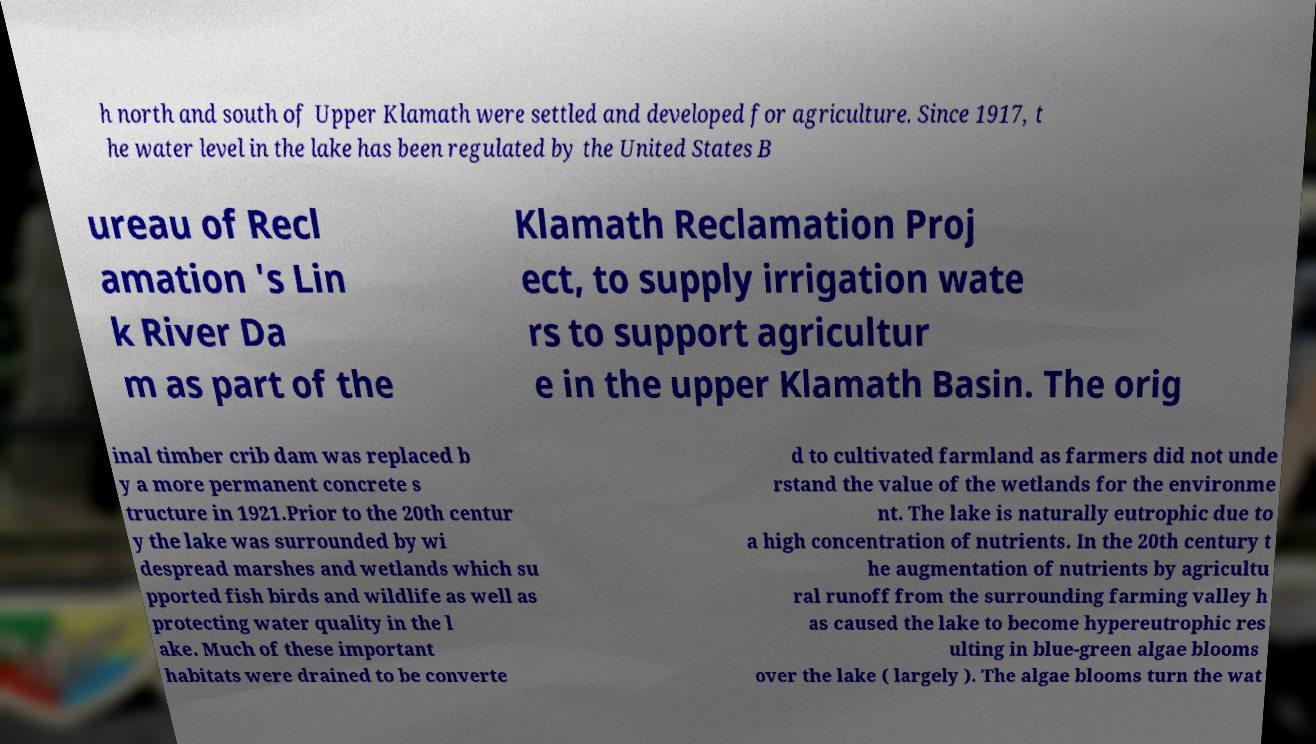There's text embedded in this image that I need extracted. Can you transcribe it verbatim? h north and south of Upper Klamath were settled and developed for agriculture. Since 1917, t he water level in the lake has been regulated by the United States B ureau of Recl amation 's Lin k River Da m as part of the Klamath Reclamation Proj ect, to supply irrigation wate rs to support agricultur e in the upper Klamath Basin. The orig inal timber crib dam was replaced b y a more permanent concrete s tructure in 1921.Prior to the 20th centur y the lake was surrounded by wi despread marshes and wetlands which su pported fish birds and wildlife as well as protecting water quality in the l ake. Much of these important habitats were drained to be converte d to cultivated farmland as farmers did not unde rstand the value of the wetlands for the environme nt. The lake is naturally eutrophic due to a high concentration of nutrients. In the 20th century t he augmentation of nutrients by agricultu ral runoff from the surrounding farming valley h as caused the lake to become hypereutrophic res ulting in blue-green algae blooms over the lake ( largely ). The algae blooms turn the wat 